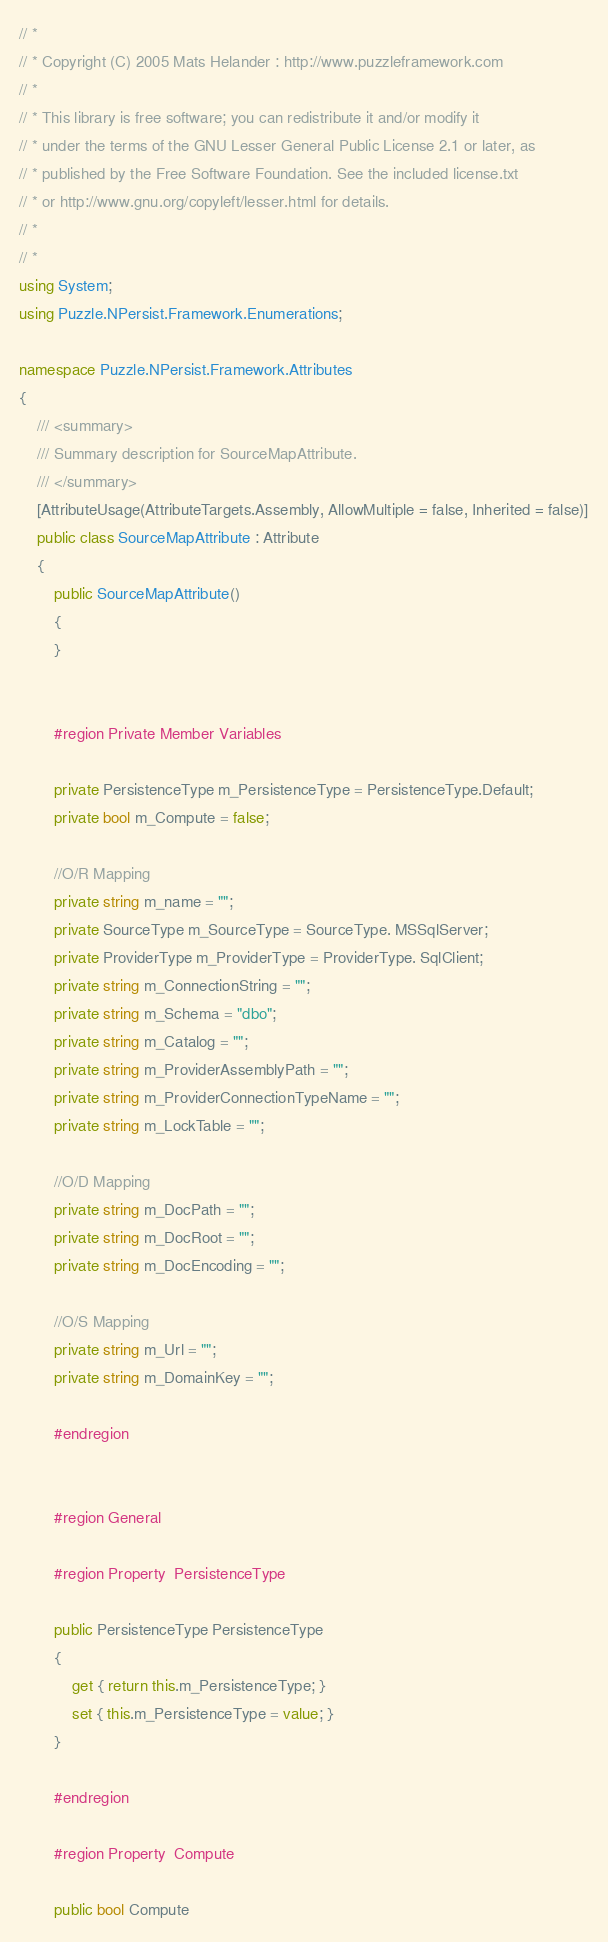<code> <loc_0><loc_0><loc_500><loc_500><_C#_>// *
// * Copyright (C) 2005 Mats Helander : http://www.puzzleframework.com
// *
// * This library is free software; you can redistribute it and/or modify it
// * under the terms of the GNU Lesser General Public License 2.1 or later, as
// * published by the Free Software Foundation. See the included license.txt
// * or http://www.gnu.org/copyleft/lesser.html for details.
// *
// *
using System;
using Puzzle.NPersist.Framework.Enumerations;

namespace Puzzle.NPersist.Framework.Attributes
{
	/// <summary>
	/// Summary description for SourceMapAttribute.
	/// </summary>
	[AttributeUsage(AttributeTargets.Assembly, AllowMultiple = false, Inherited = false)]
	public class SourceMapAttribute : Attribute
	{
		public SourceMapAttribute()
		{
		}


		#region Private Member Variables

		private PersistenceType m_PersistenceType = PersistenceType.Default;
		private bool m_Compute = false;

		//O/R Mapping
		private string m_name = "";
		private SourceType m_SourceType = SourceType. MSSqlServer;
		private ProviderType m_ProviderType = ProviderType. SqlClient;
		private string m_ConnectionString = "";
		private string m_Schema = "dbo";
		private string m_Catalog = "";
		private string m_ProviderAssemblyPath = "";
		private string m_ProviderConnectionTypeName = "";
		private string m_LockTable = "";

		//O/D Mapping
		private string m_DocPath = "";
		private string m_DocRoot = "";
		private string m_DocEncoding = "";

		//O/S Mapping
		private string m_Url = "";
		private string m_DomainKey = "";

		#endregion


		#region General

		#region Property  PersistenceType
				
		public PersistenceType PersistenceType
		{
			get { return this.m_PersistenceType; }
			set { this.m_PersistenceType = value; }
		}
		
		#endregion

		#region Property  Compute
				
		public bool Compute</code> 